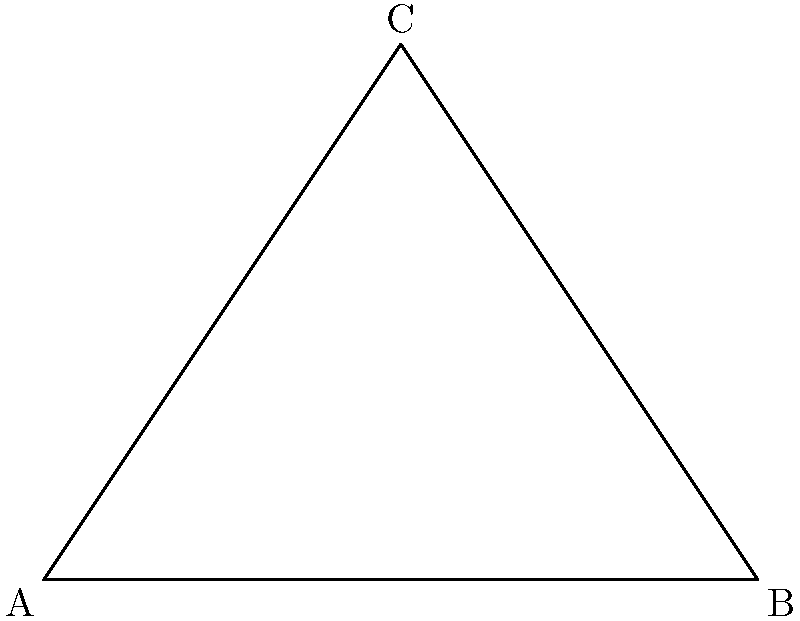In a hyperbolic triangle ABC, the angles are measured as $\alpha$, $\beta$, and $\gamma$. Unlike in Euclidean geometry, the sum of these angles in hyperbolic geometry is always less than 180°. If the sum of the angles in this hyperbolic triangle is 150°, what is the difference between this sum and the sum of angles in a Euclidean triangle? To solve this problem, let's follow these steps:

1. Recall that in Euclidean geometry, the sum of angles in a triangle is always 180°.

2. We're given that in this hyperbolic triangle, the sum of angles is 150°.

3. To find the difference, we need to subtract the hyperbolic sum from the Euclidean sum:

   $$\text{Difference} = \text{Euclidean sum} - \text{Hyperbolic sum}$$
   $$\text{Difference} = 180° - 150°$$
   $$\text{Difference} = 30°$$

4. This difference is known as the defect of the hyperbolic triangle. In hyperbolic geometry, this defect is proportional to the area of the triangle.

5. The fact that the sum of angles in a hyperbolic triangle is always less than 180° is a fundamental property of hyperbolic geometry, distinguishing it from Euclidean geometry.
Answer: 30° 